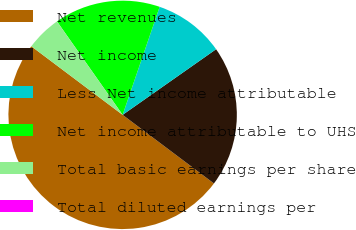Convert chart. <chart><loc_0><loc_0><loc_500><loc_500><pie_chart><fcel>Net revenues<fcel>Net income<fcel>Less Net income attributable<fcel>Net income attributable to UHS<fcel>Total basic earnings per share<fcel>Total diluted earnings per<nl><fcel>50.0%<fcel>20.0%<fcel>10.0%<fcel>15.0%<fcel>5.0%<fcel>0.0%<nl></chart> 